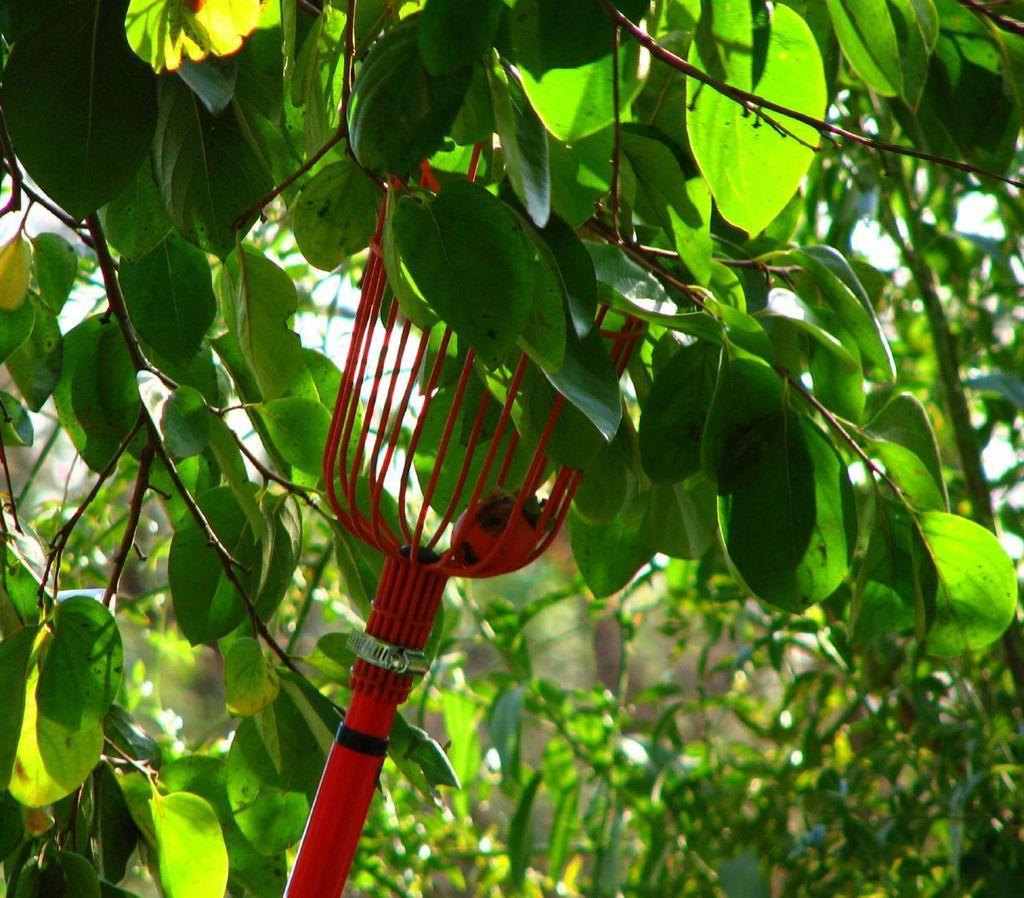Can you describe this image briefly? In this image I can see a fruit harvester tool, leaves and stems. Inside this fruit harvester tool there is a fruit.   